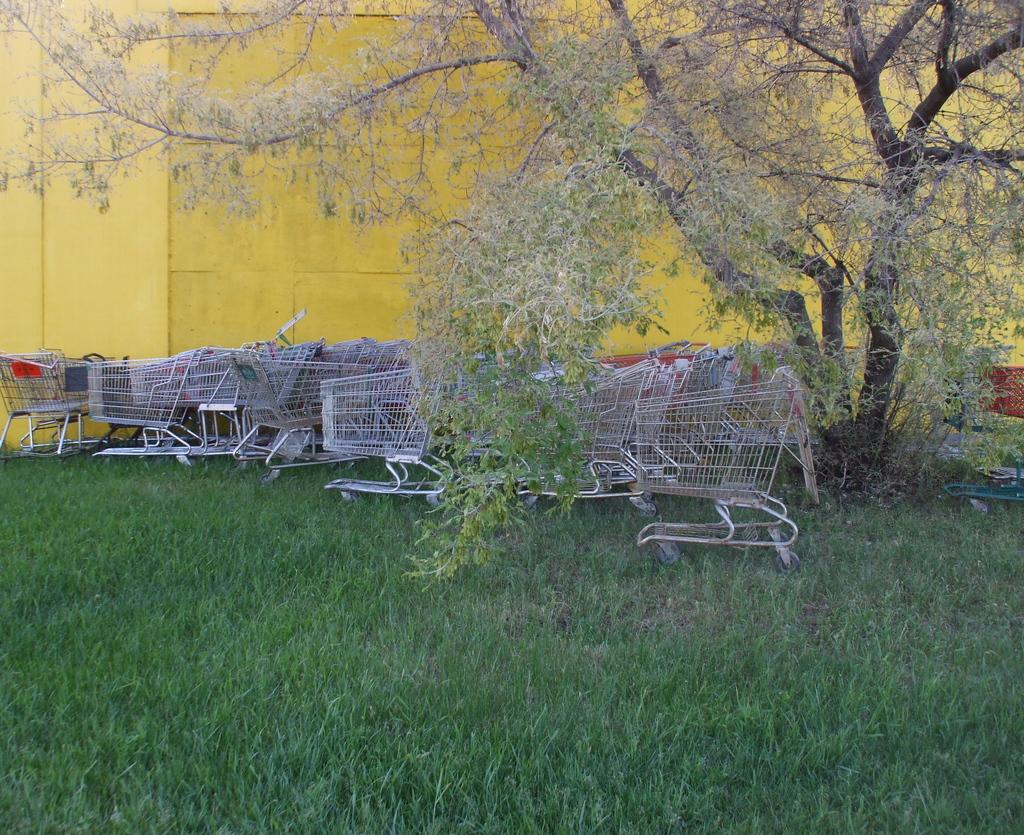What objects are on the ground in the image? There are silver shopping trolleys on the ground. What type of vegetation is present in the image? There is a grass lawn in the front bottom side of the image. Can you describe any natural elements in the image? There is a tree visible in the image. What color is the wall in the background of the image? There is a yellow wall in the background of the image. How many fish can be seen swimming in the grass lawn in the image? There are no fish present in the image, as it features a grass lawn and not a body of water. 